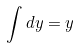<formula> <loc_0><loc_0><loc_500><loc_500>\int d y = y</formula> 